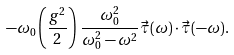<formula> <loc_0><loc_0><loc_500><loc_500>- \omega _ { 0 } \left ( \frac { g ^ { 2 } } { 2 } \right ) \, \frac { \omega _ { 0 } ^ { 2 } } { \omega _ { 0 } ^ { 2 } - \omega ^ { 2 } } \vec { \tau } ( \omega ) \cdot \vec { \tau } ( - \omega ) .</formula> 